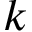Convert formula to latex. <formula><loc_0><loc_0><loc_500><loc_500>\ v { k }</formula> 